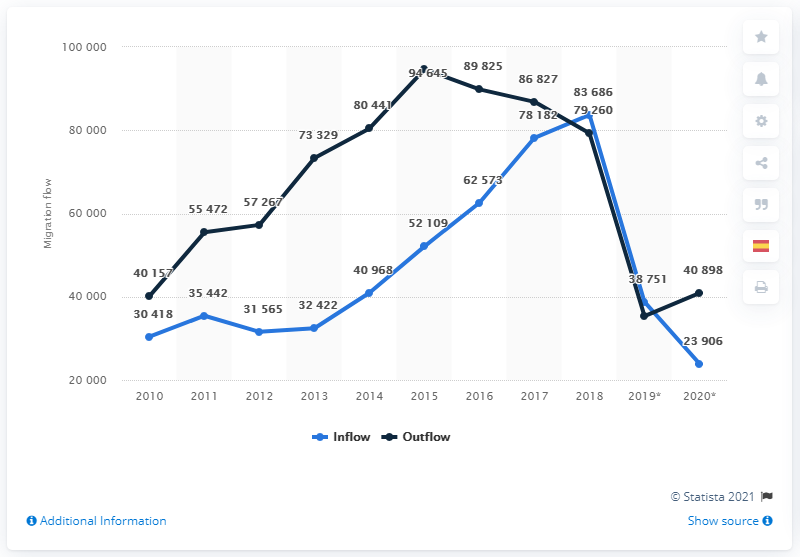How does the trend of outflow compare to the inflow of Spaniards between 2010 and 2020? The outflow of Spaniards, or those leaving Spain, consistently surpassed the inflow returning to Spain from 2010 till around 2015. Post-2015, this trend inverted with a higher number of Spaniards coming back to Spain till around 2018, after which a steep decline in both inflow and outflow is evident. What might the year 2018 signify in this context? The year 2018 could signify a turning point due to political or economic events in Spain or abroad influencing both inflow and outflow rates. It could correlate with certain policy changes, national economic adjustments, or shifts in the global economy influencing migration attitudes and possibilities for Spaniards. 